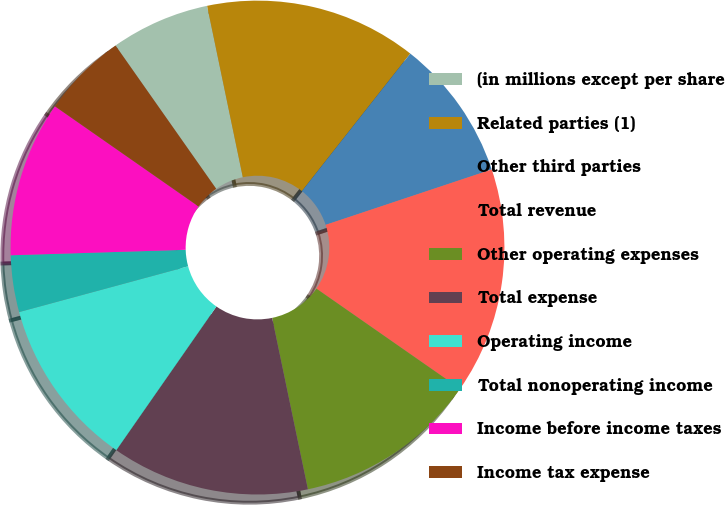Convert chart. <chart><loc_0><loc_0><loc_500><loc_500><pie_chart><fcel>(in millions except per share<fcel>Related parties (1)<fcel>Other third parties<fcel>Total revenue<fcel>Other operating expenses<fcel>Total expense<fcel>Operating income<fcel>Total nonoperating income<fcel>Income before income taxes<fcel>Income tax expense<nl><fcel>6.48%<fcel>13.89%<fcel>9.26%<fcel>14.81%<fcel>12.04%<fcel>12.96%<fcel>11.11%<fcel>3.71%<fcel>10.19%<fcel>5.56%<nl></chart> 